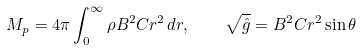<formula> <loc_0><loc_0><loc_500><loc_500>M _ { p } = 4 \pi \int _ { 0 } ^ { \infty } { \rho B ^ { 2 } C r ^ { 2 } } \, d r , \quad \sqrt { \hat { g } } = B ^ { 2 } C r ^ { 2 } \sin \theta</formula> 